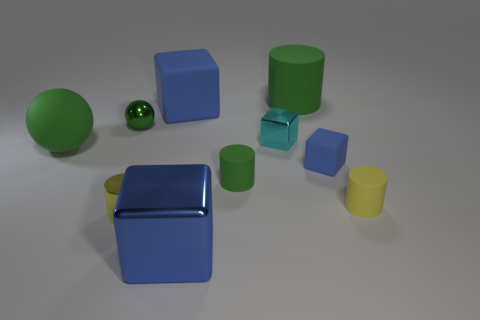Subtract all large blue matte blocks. How many blocks are left? 3 Subtract all cyan blocks. How many blocks are left? 3 Subtract 2 cubes. How many cubes are left? 2 Subtract all cubes. How many objects are left? 6 Subtract all purple blocks. How many yellow cylinders are left? 2 Subtract all blue cubes. Subtract all cyan shiny blocks. How many objects are left? 6 Add 6 tiny blocks. How many tiny blocks are left? 8 Add 5 blue rubber objects. How many blue rubber objects exist? 7 Subtract 0 yellow cubes. How many objects are left? 10 Subtract all red balls. Subtract all purple blocks. How many balls are left? 2 